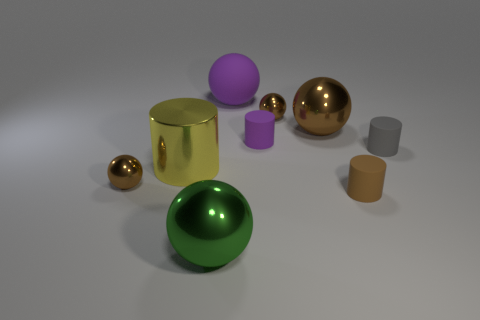There is a gray matte thing that is the same shape as the tiny brown matte thing; what is its size?
Your answer should be very brief. Small. How many tiny brown objects are made of the same material as the purple ball?
Give a very brief answer. 1. Is there a metal object that is left of the brown metallic thing on the right side of the tiny ball right of the big purple rubber thing?
Your answer should be compact. Yes. What is the shape of the large matte object?
Offer a very short reply. Sphere. Is the big sphere to the right of the rubber sphere made of the same material as the tiny cylinder behind the gray matte thing?
Provide a succinct answer. No. What number of things are the same color as the large matte ball?
Your response must be concise. 1. The thing that is both to the right of the big purple rubber thing and behind the big brown sphere has what shape?
Make the answer very short. Sphere. What color is the metal ball that is behind the small brown matte thing and left of the purple cylinder?
Provide a succinct answer. Brown. Is the number of small matte cylinders that are in front of the tiny gray object greater than the number of big yellow cylinders in front of the yellow shiny cylinder?
Offer a very short reply. Yes. There is a tiny shiny sphere that is to the left of the large green thing; what is its color?
Provide a succinct answer. Brown. 